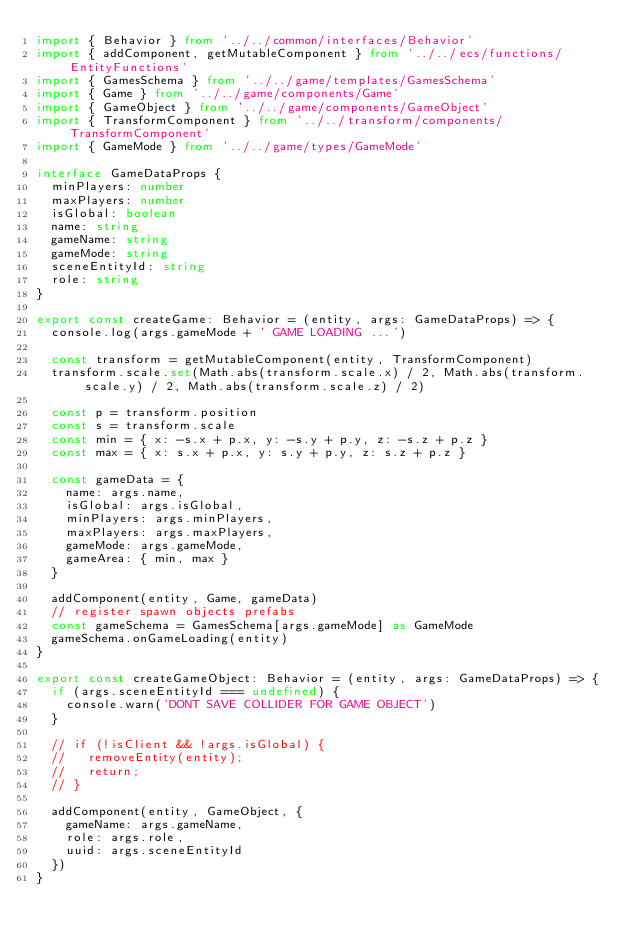Convert code to text. <code><loc_0><loc_0><loc_500><loc_500><_TypeScript_>import { Behavior } from '../../common/interfaces/Behavior'
import { addComponent, getMutableComponent } from '../../ecs/functions/EntityFunctions'
import { GamesSchema } from '../../game/templates/GamesSchema'
import { Game } from '../../game/components/Game'
import { GameObject } from '../../game/components/GameObject'
import { TransformComponent } from '../../transform/components/TransformComponent'
import { GameMode } from '../../game/types/GameMode'

interface GameDataProps {
  minPlayers: number
  maxPlayers: number
  isGlobal: boolean
  name: string
  gameName: string
  gameMode: string
  sceneEntityId: string
  role: string
}

export const createGame: Behavior = (entity, args: GameDataProps) => {
  console.log(args.gameMode + ' GAME LOADING ...')

  const transform = getMutableComponent(entity, TransformComponent)
  transform.scale.set(Math.abs(transform.scale.x) / 2, Math.abs(transform.scale.y) / 2, Math.abs(transform.scale.z) / 2)

  const p = transform.position
  const s = transform.scale
  const min = { x: -s.x + p.x, y: -s.y + p.y, z: -s.z + p.z }
  const max = { x: s.x + p.x, y: s.y + p.y, z: s.z + p.z }

  const gameData = {
    name: args.name,
    isGlobal: args.isGlobal,
    minPlayers: args.minPlayers,
    maxPlayers: args.maxPlayers,
    gameMode: args.gameMode,
    gameArea: { min, max }
  }

  addComponent(entity, Game, gameData)
  // register spawn objects prefabs
  const gameSchema = GamesSchema[args.gameMode] as GameMode
  gameSchema.onGameLoading(entity)
}

export const createGameObject: Behavior = (entity, args: GameDataProps) => {
  if (args.sceneEntityId === undefined) {
    console.warn('DONT SAVE COLLIDER FOR GAME OBJECT')
  }

  // if (!isClient && !args.isGlobal) {
  //   removeEntity(entity);
  //   return;
  // }

  addComponent(entity, GameObject, {
    gameName: args.gameName,
    role: args.role,
    uuid: args.sceneEntityId
  })
}
</code> 